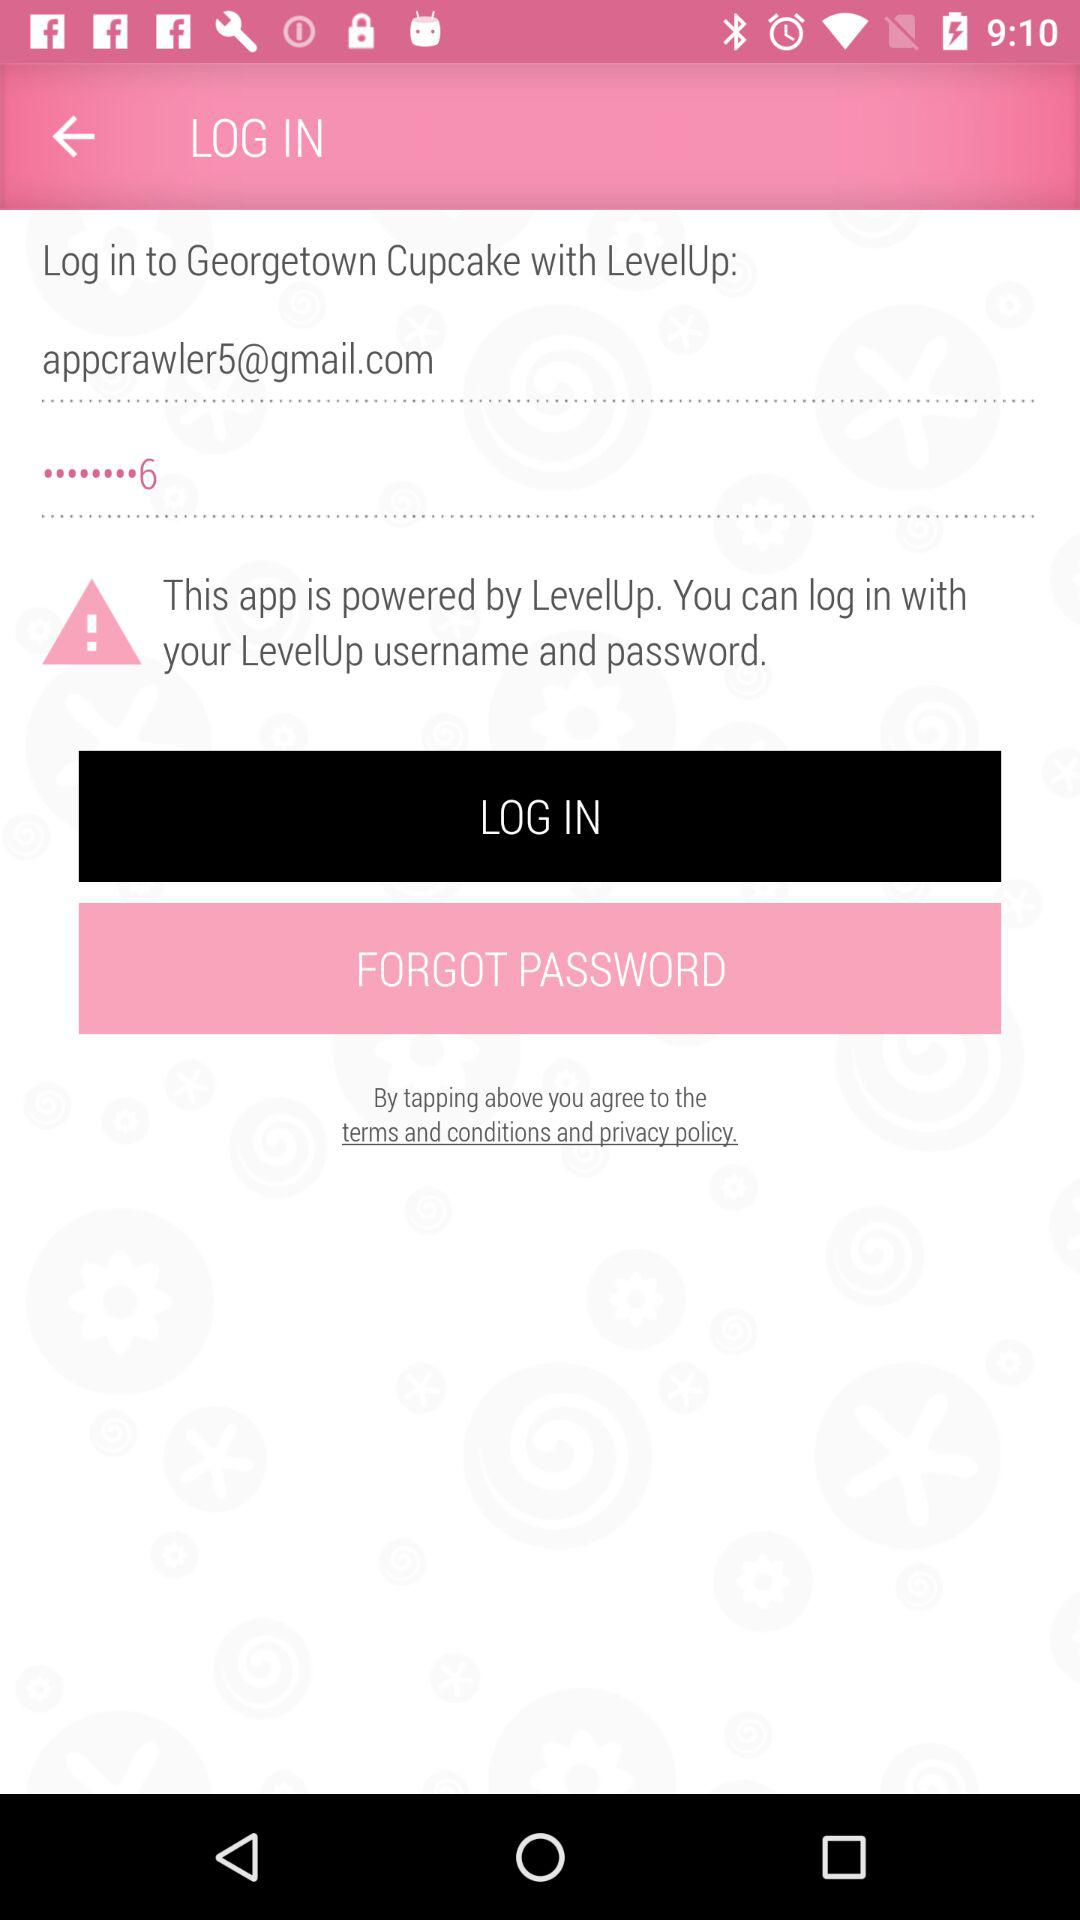What is the application name? The application name is "Georgetown Cupcake". 